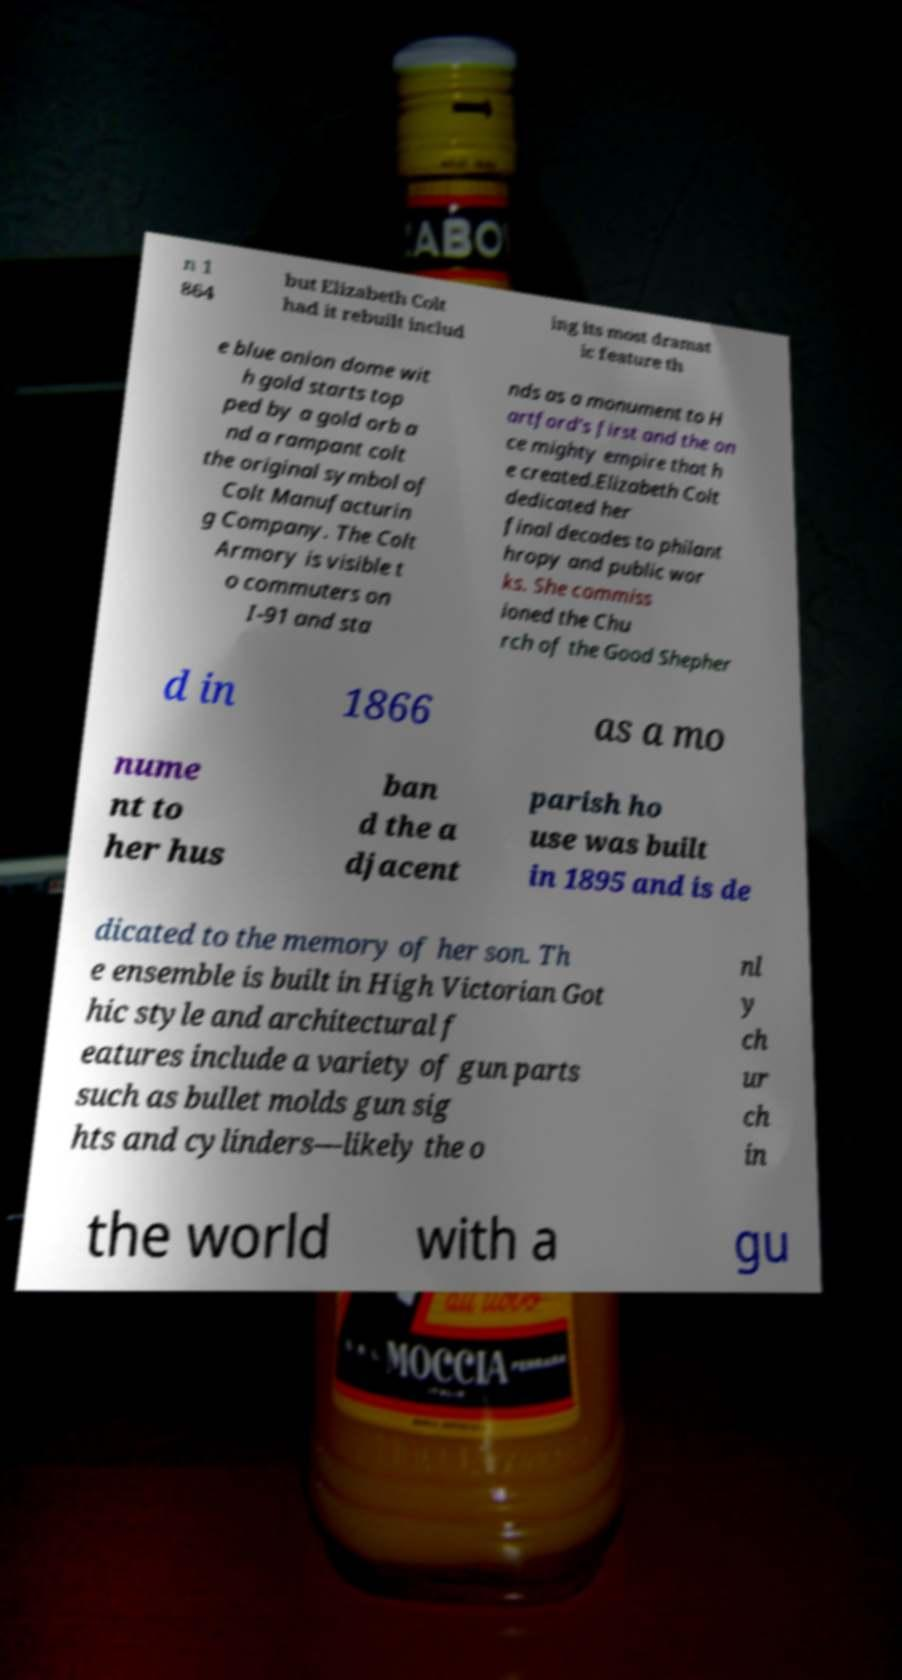Could you assist in decoding the text presented in this image and type it out clearly? n 1 864 but Elizabeth Colt had it rebuilt includ ing its most dramat ic feature th e blue onion dome wit h gold starts top ped by a gold orb a nd a rampant colt the original symbol of Colt Manufacturin g Company. The Colt Armory is visible t o commuters on I-91 and sta nds as a monument to H artford's first and the on ce mighty empire that h e created.Elizabeth Colt dedicated her final decades to philant hropy and public wor ks. She commiss ioned the Chu rch of the Good Shepher d in 1866 as a mo nume nt to her hus ban d the a djacent parish ho use was built in 1895 and is de dicated to the memory of her son. Th e ensemble is built in High Victorian Got hic style and architectural f eatures include a variety of gun parts such as bullet molds gun sig hts and cylinders—likely the o nl y ch ur ch in the world with a gu 